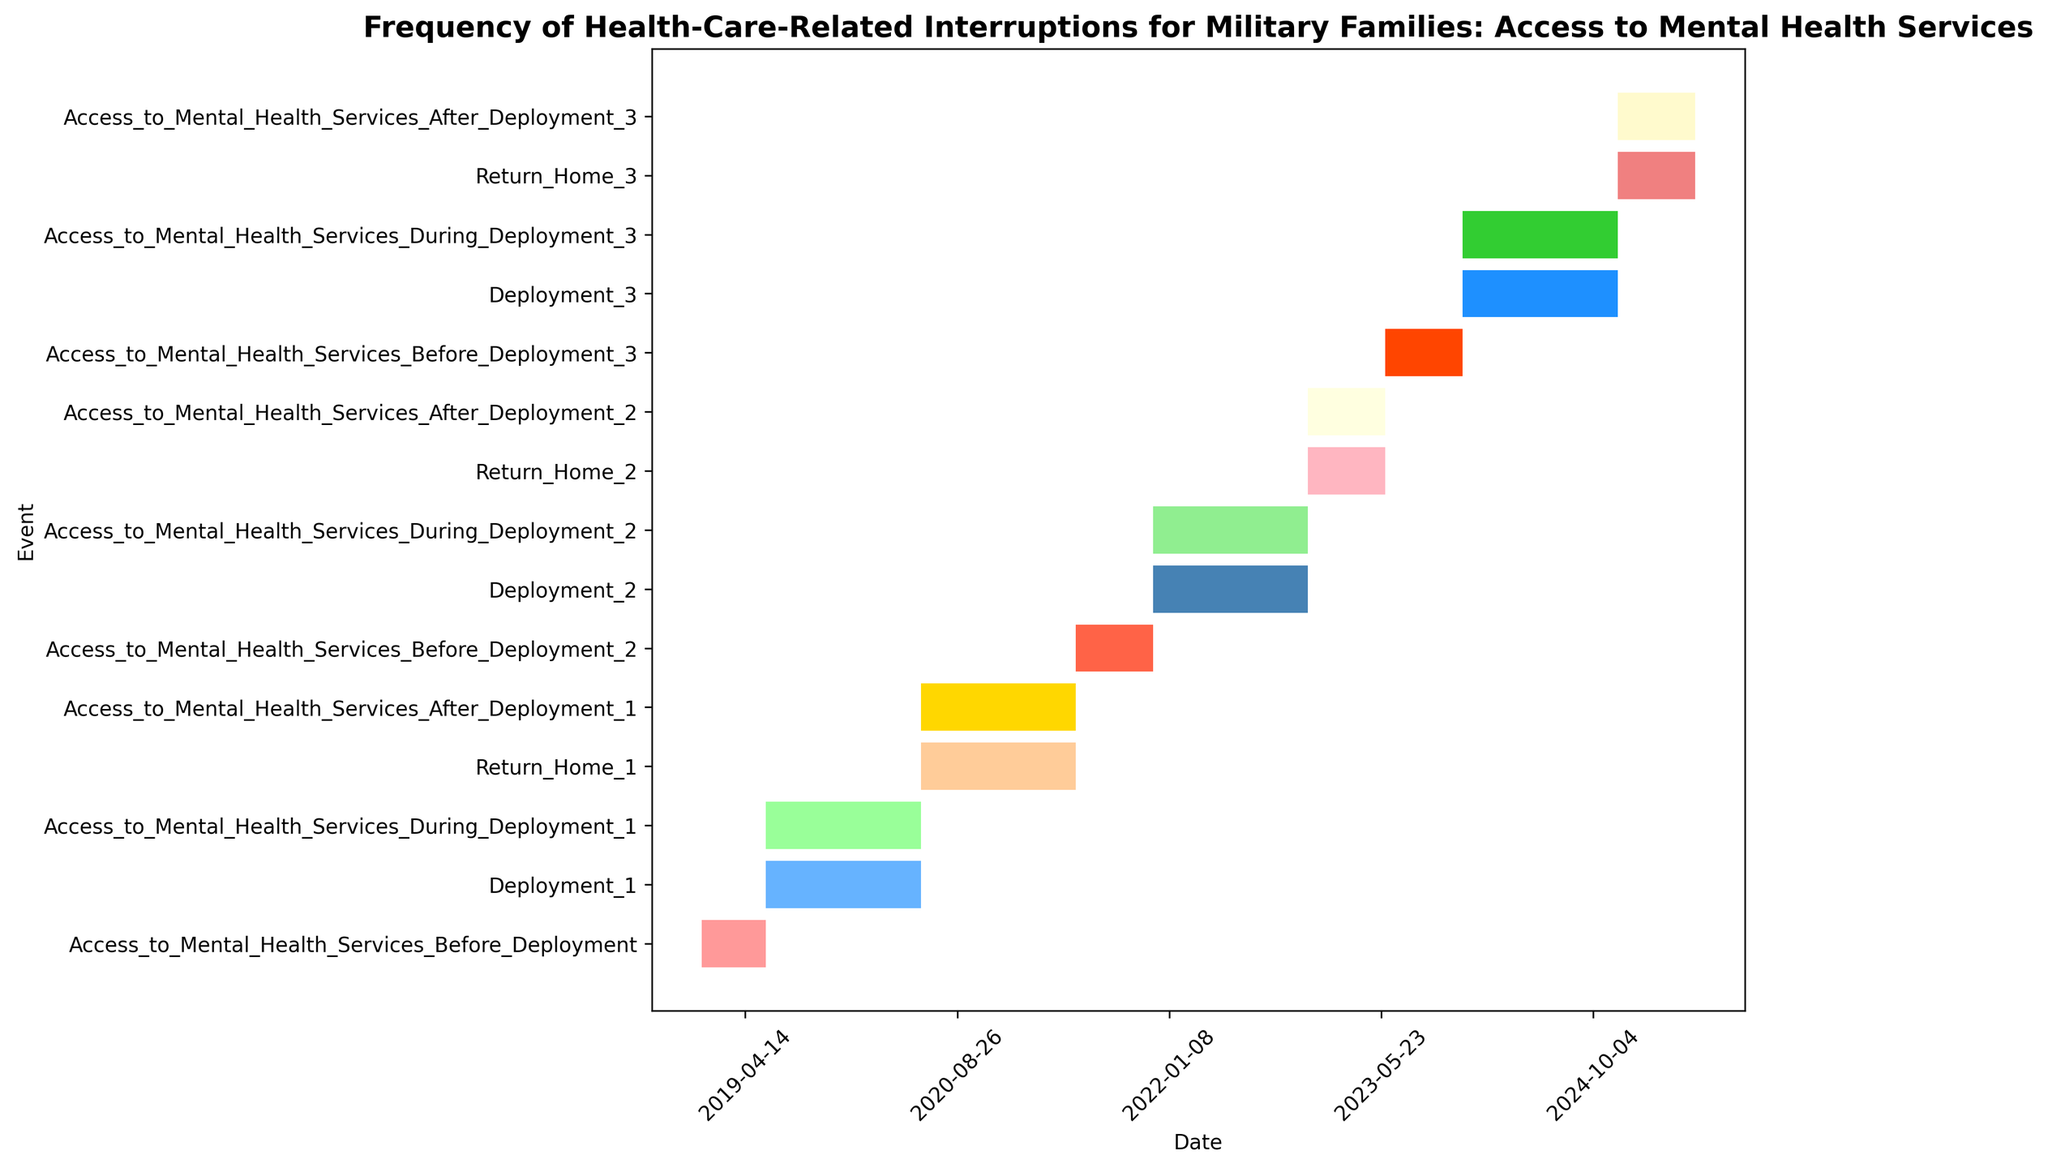Which deployment period was the longest? To determine which deployment period was the longest, we need to compare the length of Deployment_1, Deployment_2, and Deployment_3. Deployment_1 spans from 2019-06-01 to 2020-06-01 (1 year), Deployment_2 from 2021-12-01 to 2022-12-01 (1 year), and Deployment_3 from 2023-12-01 to 2024-12-01 (1 year). Since all deployments are of equal duration, each for 1 year.
Answer: All deployments are of equal duration Which event has the longest duration in the plot? To find the event with the longest duration, compare the start and end dates of all events. The event "Access_to_Mental_Health_Services_After_Deployment_1" spans from 2020-06-01 to 2021-06-01 (1 year), similar to other events having a duration of exactly 1 year. Some events like "Access_to_Mental_Health_Services_Before_Deployment_2" have shorter durations (6 months or less) than deployments and access periods which are typically 1 year.
Answer: Deployment and Access to Mental Health Services periods during and after deployments (all 1 year) Which period had the least interruption in mental health services access during deployments? Compare access periods during deployments: During Deployment_1 (2019-06-01 to 2020-06-01), Deployment_2 (2021-12-01 to 2022-12-01), and Deployment_3 (2023-12-01 to 2024-12-01). Each indicates uninterrupted access during its deployment period. Thus, there was no interruption in mental health services within each deployment period.
Answer: No interruption within each deployment period How did the durations of mental health access before each deployment change over time? Examine the durations before each deployment: Before Deployment_1 (2019-01-01 to 2019-06-01: 6 months), Before Deployment_2 (2021-06-01 to 2021-12-01: 6 months), Before Deployment_3 (2023-06-01 to 2023-12-01: 6 months). The durations remained the same at 6 months before each deployment.
Answer: No change in duration (remained 6 months) Which event directly follows each deployment period? Identify events starting immediately after each deployment: After Deployment_1 (2019-06-01 to 2020-06-01) is Return_Home_1 (2020-06-01), after Deployment_2 (2021-12-01 to 2022-12-01) is Return_Home_2 (2022-12-01), after Deployment_3 (2023-12-01 to 2024-12-01) is Return_Home_3 (2024-12-01).
Answer: Return_Home after each deployment Was there any overlap between deployments and return periods? Check the end date of each deployment and the start date of corresponding return periods. Example: Deployment_1 ends on 2020-06-01 and Return_Home_1 starts on the same date. Deployment_2 ends on 2022-12-01; Return_Home_2 starts the same date. Deployment_3 ends on 2024-12-01; Return_Home_3 starts the same date. Therefore, the deployments transitioned directly into return periods without any overlap.
Answer: No overlap, direct transitions 